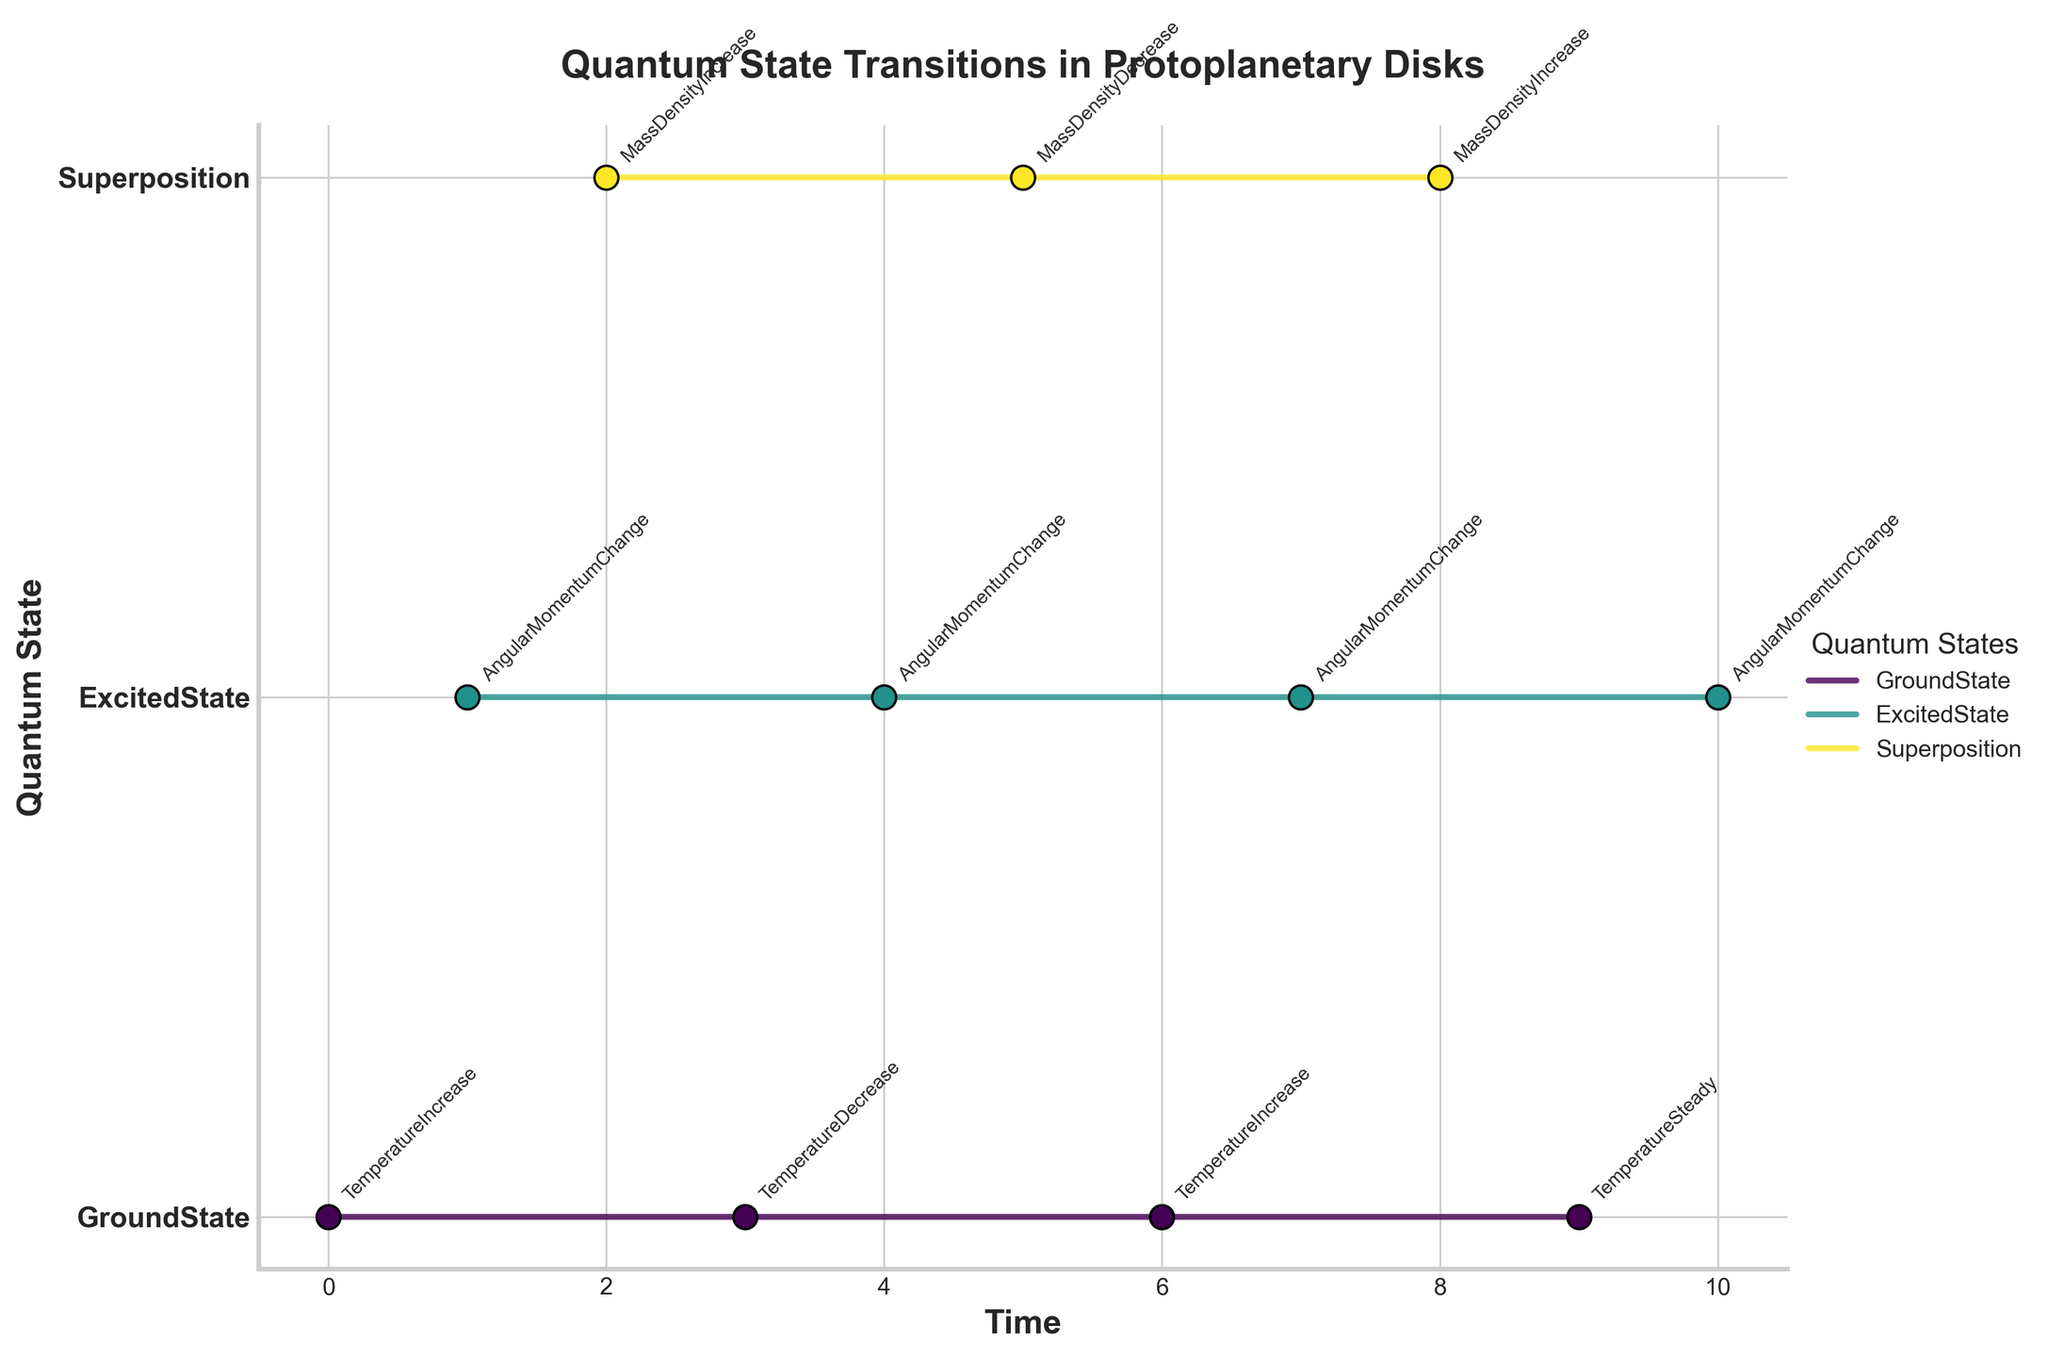What is the title of the figure? The title is usually displayed at the top of the figure in a larger and bolder font.
Answer: Quantum State Transitions in Protoplanetary Disks Which quantum state appears most frequently? We need to count how many times each quantum state appears in the plot. GroundState appears 4 times, ExcitedState 4 times, and Superposition 3 times.
Answer: GroundState and ExcitedState At which time points does the temperature increase? We locate the annotations associated with "TemperatureIncrease" and then note the corresponding time points. These are at times 0 and 6.
Answer: 0 and 6 When does the quantum state remain steady (neither increase nor decrease in any property)? We look for where the annotation "TemperatureSteady" appears on the plot, and find that it occurs at time 9.
Answer: 9 Compare the mass density changes for Superposition states at different time points. We find the annotations related to "MassDensity" under the Superposition state and notice that there are increases at times 2 and 8, and a decrease at time 5.
Answer: Increases at 2 and 8, decreases at 5 How many transitions involve an angular momentum change, and when do they occur? We count the annotations labeled "AngularMomentumChange" and note their corresponding time points. These occur at times 1, 4, 7, and 10. So there are 4 such transitions.
Answer: 4 transitions at times 1, 4, 7, and 10 What is the longest duration a quantum state remains unchanged? We examine the stair steps to see the largest gap in time before a change occurs for any one state. For instance, Superposition stays unchanged from time 2 to 5 and from 8 to 9, each lasting 3 units of time. However, GroundState stays unchanged from 6 to 9 which is 3 units too. The longest is thus 3 units.
Answer: 3 units of time Do any quantum states return to their initial properties by the end of the time period? We need to compare the initial properties with those at the end of the timeline for each state. The last recorded state for each is as follows:
- GroundState initially increases temperature, and ends with temperature being steady, therefore not returning to the initial state.
- ExcitedState initially changes angular momentum and the same change occurs at the end too.
- Superposition doesn't change its property to the one at the start.
So none return to their exact initial properties.
Answer: No 